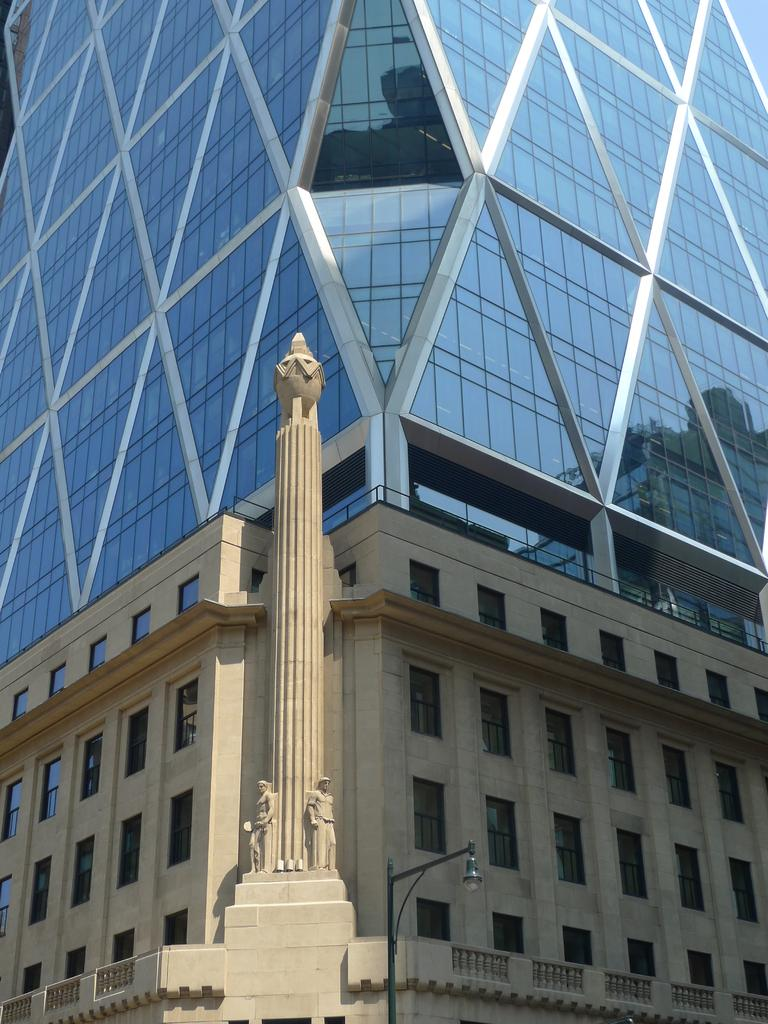What is the main structure in the center of the image? There is a pillar in the center of the image. What can be seen in the distance behind the pillar? There are buildings in the background of the image. What is the object at the bottom of the image? There is a light pole at the bottom of the image. How many yams are being delivered in the parcel shown in the image? There is no parcel or yams present in the image. 